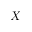Convert formula to latex. <formula><loc_0><loc_0><loc_500><loc_500>X</formula> 